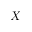Convert formula to latex. <formula><loc_0><loc_0><loc_500><loc_500>X</formula> 